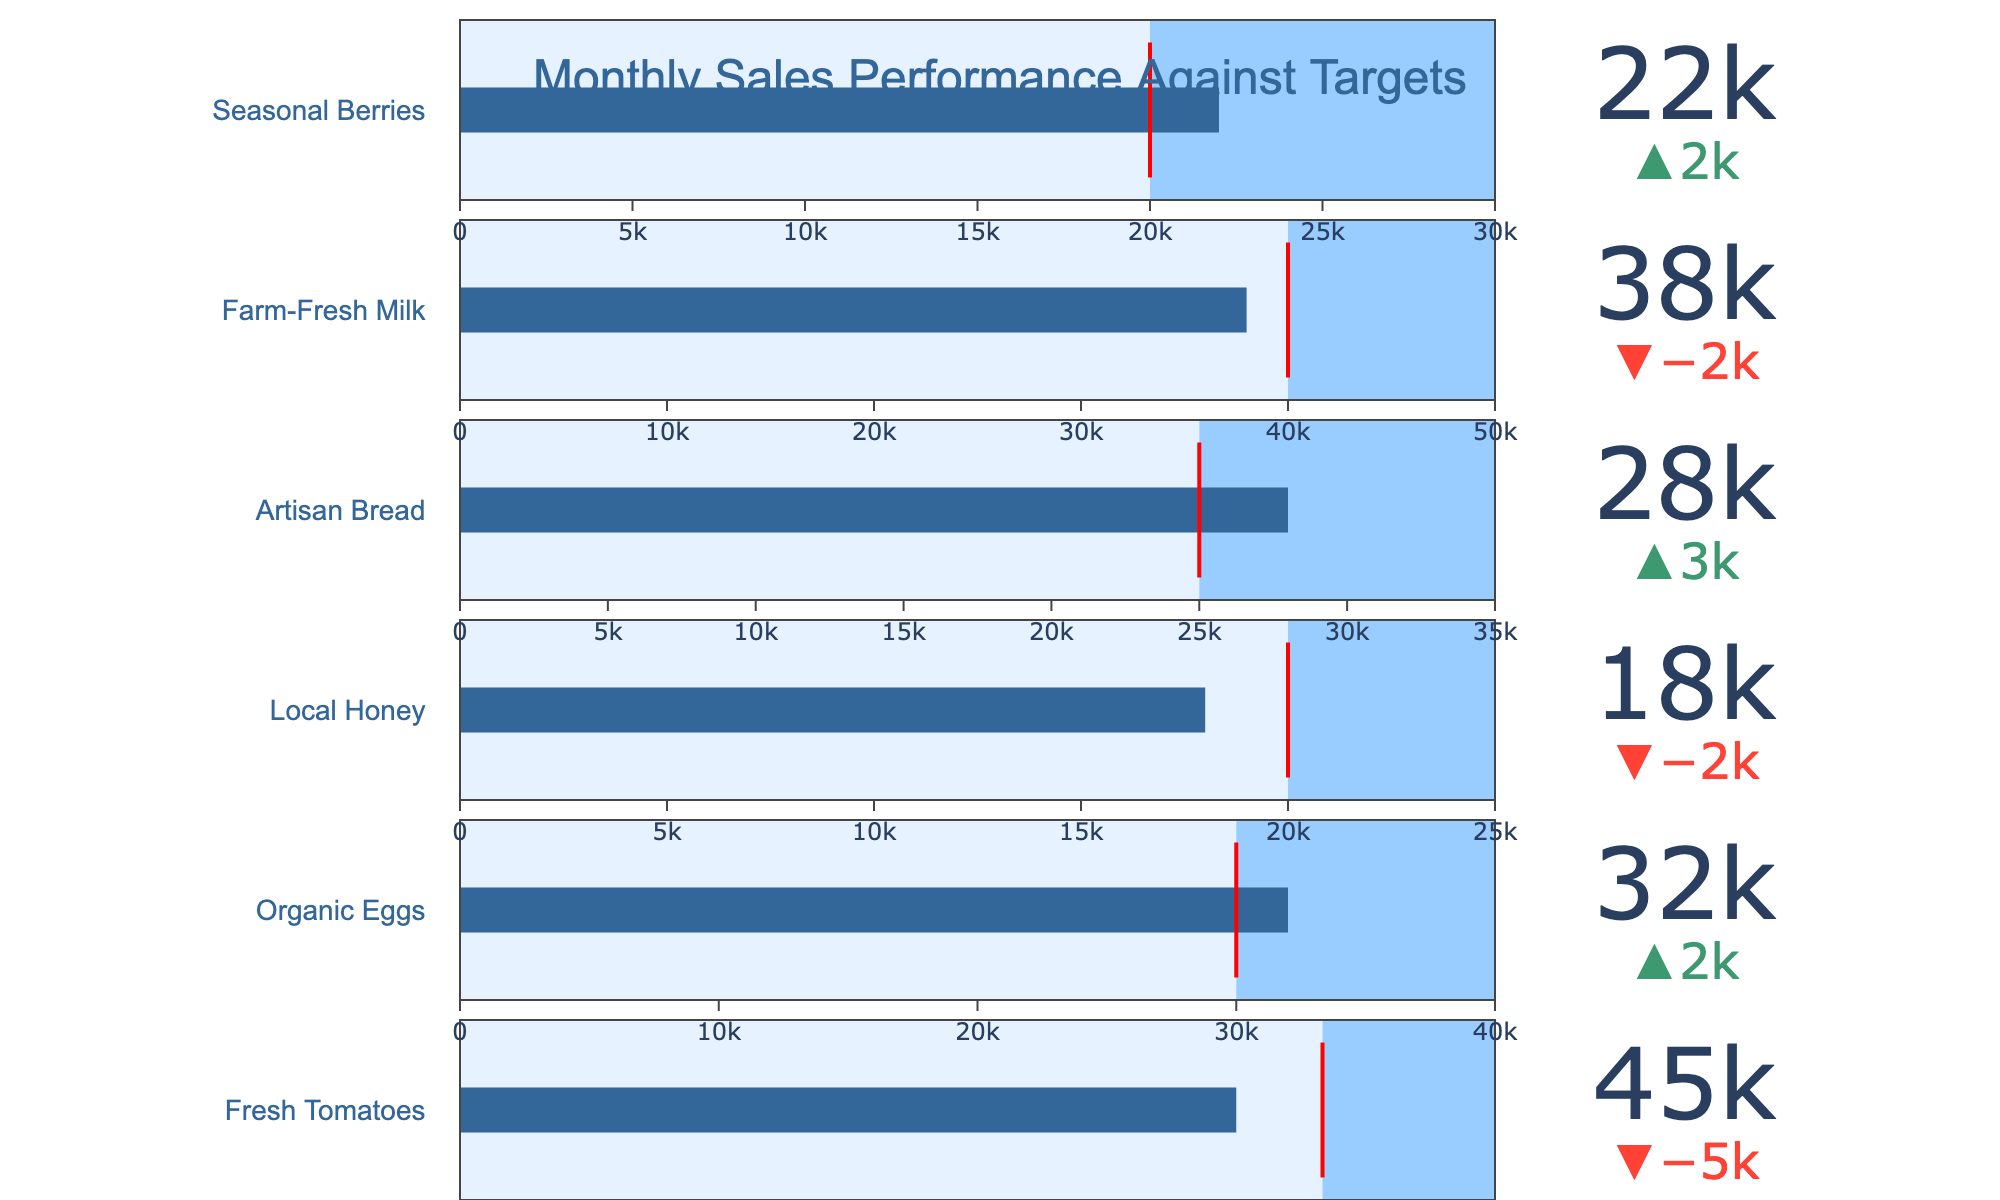What's the title of the figure? The title of the figure is displayed prominently at the top-center of the chart. It reads "Monthly Sales Performance Against Targets".
Answer: Monthly Sales Performance Against Targets How many products are displayed in the figure? The figure shows Bullet Charts for each of the listed products. Count the number of chart indicators displayed. There are six products.
Answer: Six Which product has the highest actual sales? Compare the values under "Actual Sales" for each product. Fresh Tomatoes has the highest at 45000.
Answer: Fresh Tomatoes Which product exceeded its sales target? By looking at the delta indicators for each product, Local Honey (Actual: 18000, Target: 20000), Fresh Tomatoes (Actual: 45000, Target: 50000), and Farm-Fresh Milk (Actual: 38000, Target: 40000) missed their targets. Organic Eggs (Actual: 32000, Target: 30000), Artisan Bread (Actual: 28000, Target: 25000), and Seasonal Berries (Actual: 22000, Target: 20000) exceeded theirs.
Answer: Organic Eggs, Artisan Bread, Seasonal Berries How much is the actual sales of Local Honey below its target? Subtract the actual sales of Local Honey from its target sales: 20000 - 18000 = 2000.
Answer: 2000 Which product is closest to meeting its target? Calculate the difference between the actual sales and the target for each product and find the smallest positive difference. Farm-Fresh Milk has a difference of 2000 (40000 - 38000).
Answer: Farm-Fresh Milk What's the average target sales for all products? Sum up all the target sales and divide by the number of products: (50000 + 30000 + 20000 + 25000 + 40000 + 20000) / 6 = 30833.33.
Answer: 30833.33 Are there more products that met or exceeded their targets than those that did not? Count the number of products that met or exceeded their targets versus those that didn't. Three met or exceeded (Organic Eggs, Artisan Bread, Seasonal Berries) and three did not (Fresh Tomatoes, Local Honey, Farm-Fresh Milk).
Answer: The numbers are equal Which product has the highest maximum sales target? Compare the values under the "Maximum" column to find the highest value. Fresh Tomatoes has the highest maximum of 60000.
Answer: Fresh Tomatoes Do any products have their actual sales between their target and maximum values? For each product, check if the actual sales fall between the target and maximum values. Fresh Tomatoes (45000 is between 50000 and 60000) is the product where actual sales fall into this range.
Answer: Fresh Tomatoes 